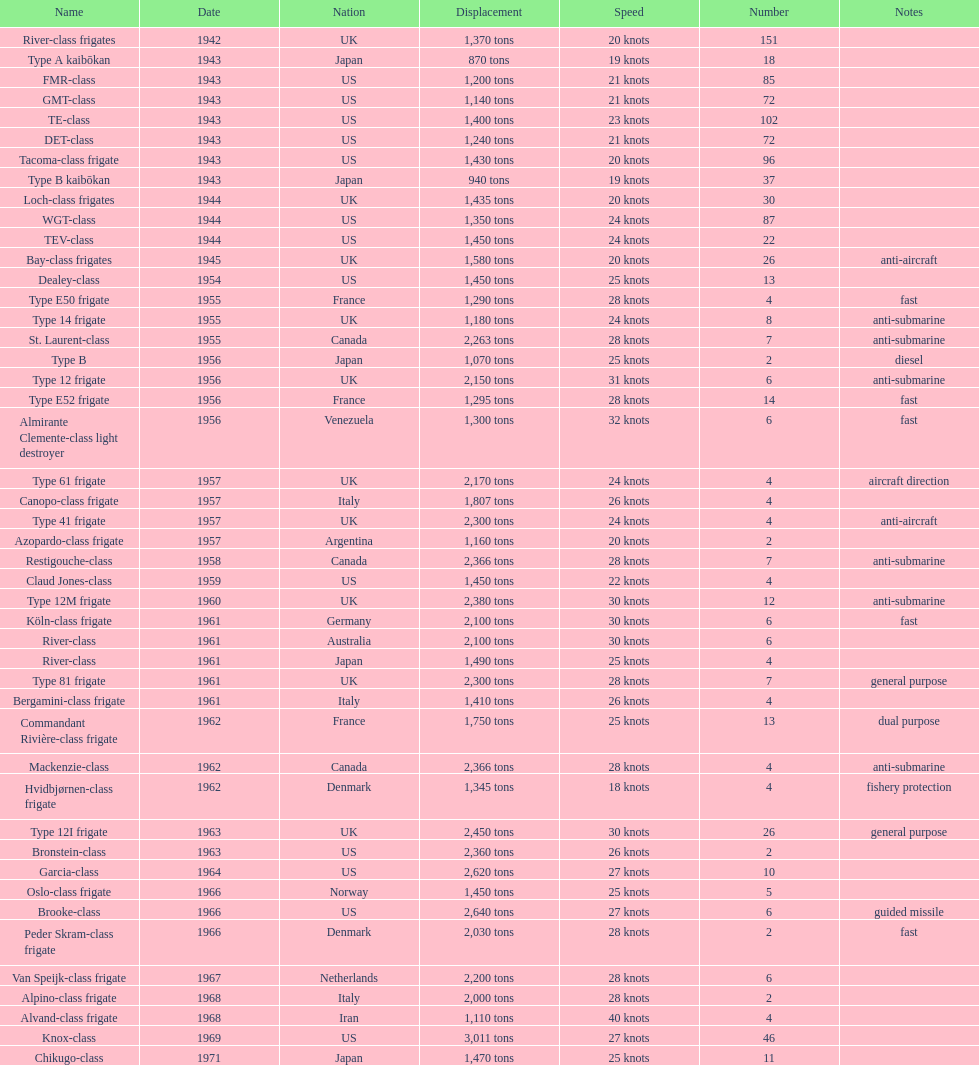How many tons does the te-class displace? 1,400 tons. 